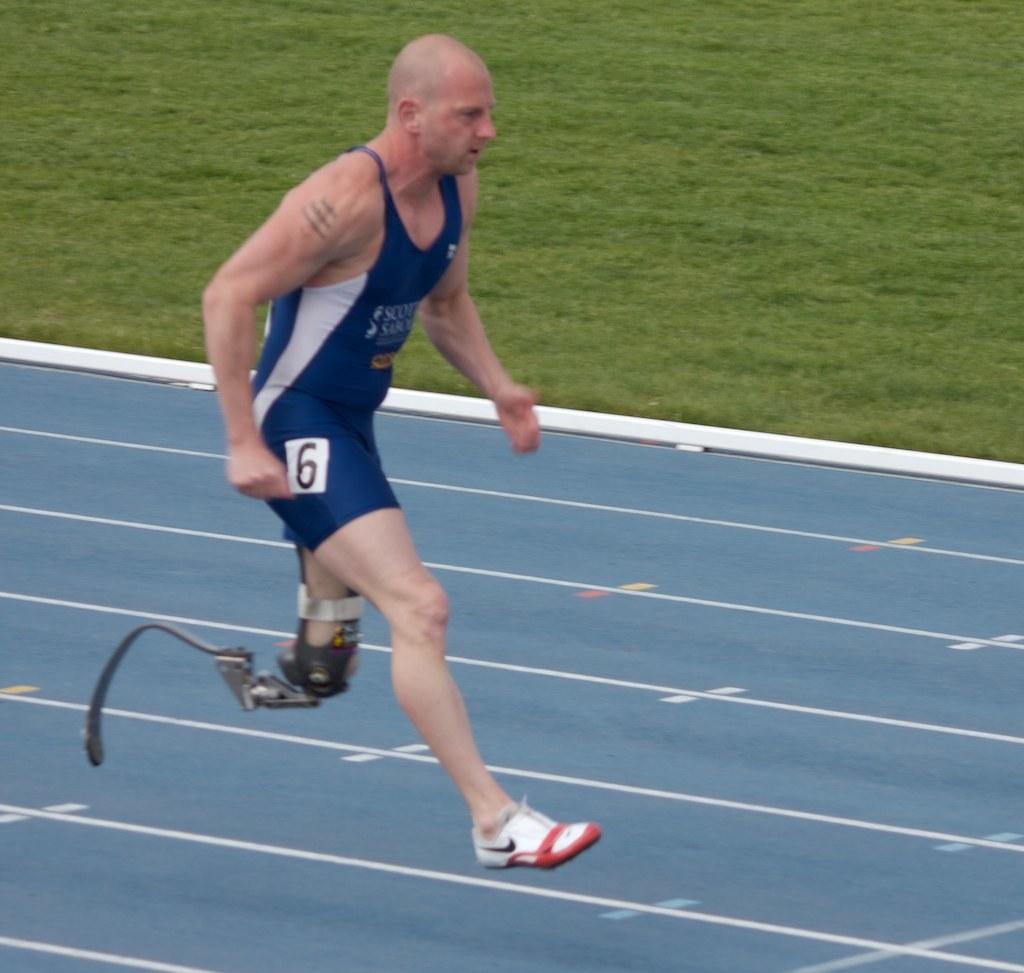Could you give a brief overview of what you see in this image? In this image, we can see a person is running on the ground. Background we can see the grass. 